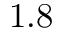<formula> <loc_0><loc_0><loc_500><loc_500>1 . 8</formula> 